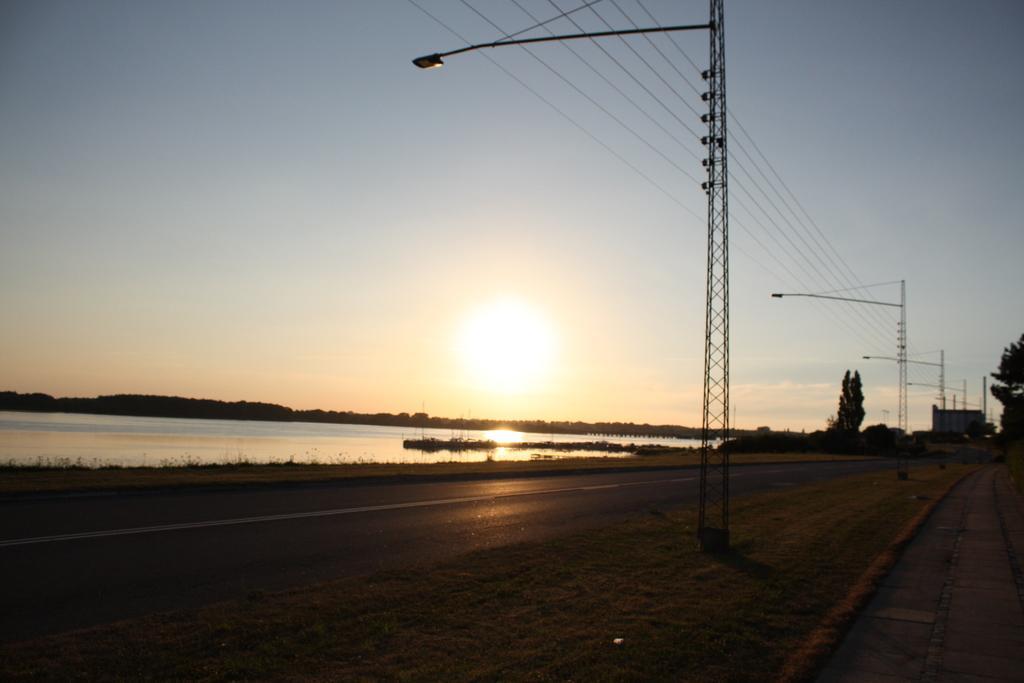In one or two sentences, can you explain what this image depicts? In this image, we can see utility poles along with wires and on the right, there are trees and at the bottom, there is water and road. 